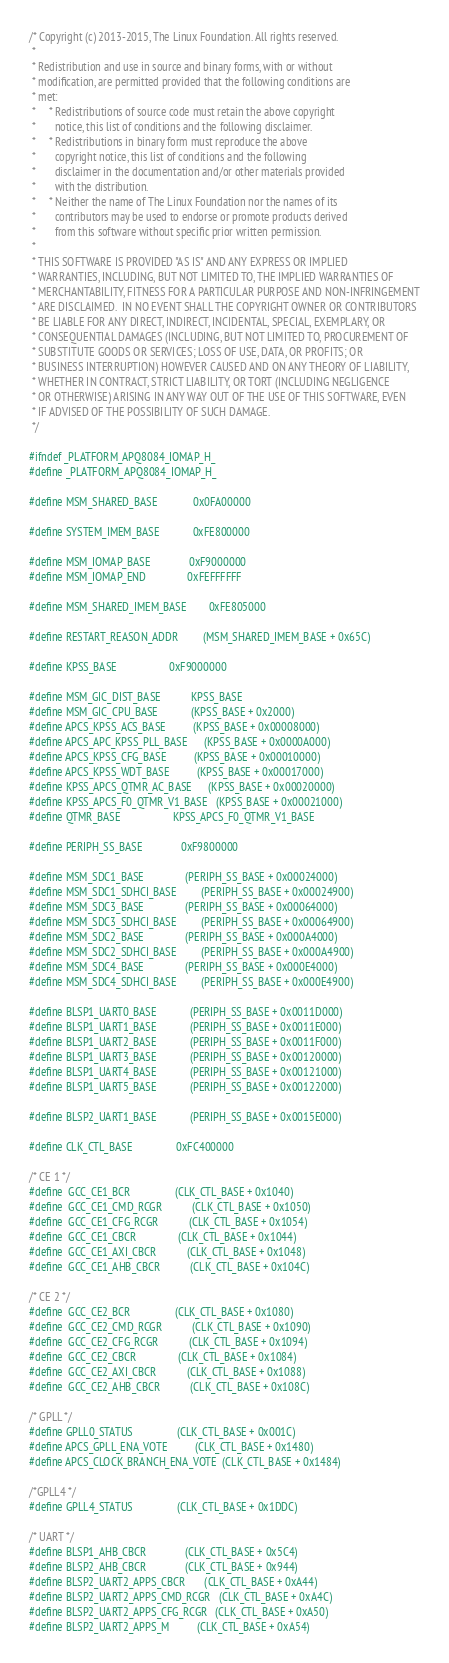Convert code to text. <code><loc_0><loc_0><loc_500><loc_500><_C_>/* Copyright (c) 2013-2015, The Linux Foundation. All rights reserved.
 *
 * Redistribution and use in source and binary forms, with or without
 * modification, are permitted provided that the following conditions are
 * met:
 *     * Redistributions of source code must retain the above copyright
 *       notice, this list of conditions and the following disclaimer.
 *     * Redistributions in binary form must reproduce the above
 *       copyright notice, this list of conditions and the following
 *       disclaimer in the documentation and/or other materials provided
 *       with the distribution.
 *     * Neither the name of The Linux Foundation nor the names of its
 *       contributors may be used to endorse or promote products derived
 *       from this software without specific prior written permission.
 *
 * THIS SOFTWARE IS PROVIDED "AS IS" AND ANY EXPRESS OR IMPLIED
 * WARRANTIES, INCLUDING, BUT NOT LIMITED TO, THE IMPLIED WARRANTIES OF
 * MERCHANTABILITY, FITNESS FOR A PARTICULAR PURPOSE AND NON-INFRINGEMENT
 * ARE DISCLAIMED.  IN NO EVENT SHALL THE COPYRIGHT OWNER OR CONTRIBUTORS
 * BE LIABLE FOR ANY DIRECT, INDIRECT, INCIDENTAL, SPECIAL, EXEMPLARY, OR
 * CONSEQUENTIAL DAMAGES (INCLUDING, BUT NOT LIMITED TO, PROCUREMENT OF
 * SUBSTITUTE GOODS OR SERVICES; LOSS OF USE, DATA, OR PROFITS; OR
 * BUSINESS INTERRUPTION) HOWEVER CAUSED AND ON ANY THEORY OF LIABILITY,
 * WHETHER IN CONTRACT, STRICT LIABILITY, OR TORT (INCLUDING NEGLIGENCE
 * OR OTHERWISE) ARISING IN ANY WAY OUT OF THE USE OF THIS SOFTWARE, EVEN
 * IF ADVISED OF THE POSSIBILITY OF SUCH DAMAGE.
 */

#ifndef _PLATFORM_APQ8084_IOMAP_H_
#define _PLATFORM_APQ8084_IOMAP_H_

#define MSM_SHARED_BASE             0x0FA00000

#define SYSTEM_IMEM_BASE            0xFE800000

#define MSM_IOMAP_BASE              0xF9000000
#define MSM_IOMAP_END               0xFEFFFFFF

#define MSM_SHARED_IMEM_BASE        0xFE805000

#define RESTART_REASON_ADDR         (MSM_SHARED_IMEM_BASE + 0x65C)

#define KPSS_BASE                   0xF9000000

#define MSM_GIC_DIST_BASE           KPSS_BASE
#define MSM_GIC_CPU_BASE            (KPSS_BASE + 0x2000)
#define APCS_KPSS_ACS_BASE          (KPSS_BASE + 0x00008000)
#define APCS_APC_KPSS_PLL_BASE      (KPSS_BASE + 0x0000A000)
#define APCS_KPSS_CFG_BASE          (KPSS_BASE + 0x00010000)
#define APCS_KPSS_WDT_BASE          (KPSS_BASE + 0x00017000)
#define KPSS_APCS_QTMR_AC_BASE      (KPSS_BASE + 0x00020000)
#define KPSS_APCS_F0_QTMR_V1_BASE   (KPSS_BASE + 0x00021000)
#define QTMR_BASE                   KPSS_APCS_F0_QTMR_V1_BASE

#define PERIPH_SS_BASE              0xF9800000

#define MSM_SDC1_BASE               (PERIPH_SS_BASE + 0x00024000)
#define MSM_SDC1_SDHCI_BASE         (PERIPH_SS_BASE + 0x00024900)
#define MSM_SDC3_BASE               (PERIPH_SS_BASE + 0x00064000)
#define MSM_SDC3_SDHCI_BASE         (PERIPH_SS_BASE + 0x00064900)
#define MSM_SDC2_BASE               (PERIPH_SS_BASE + 0x000A4000)
#define MSM_SDC2_SDHCI_BASE         (PERIPH_SS_BASE + 0x000A4900)
#define MSM_SDC4_BASE               (PERIPH_SS_BASE + 0x000E4000)
#define MSM_SDC4_SDHCI_BASE         (PERIPH_SS_BASE + 0x000E4900)

#define BLSP1_UART0_BASE            (PERIPH_SS_BASE + 0x0011D000)
#define BLSP1_UART1_BASE            (PERIPH_SS_BASE + 0x0011E000)
#define BLSP1_UART2_BASE            (PERIPH_SS_BASE + 0x0011F000)
#define BLSP1_UART3_BASE            (PERIPH_SS_BASE + 0x00120000)
#define BLSP1_UART4_BASE            (PERIPH_SS_BASE + 0x00121000)
#define BLSP1_UART5_BASE            (PERIPH_SS_BASE + 0x00122000)

#define BLSP2_UART1_BASE            (PERIPH_SS_BASE + 0x0015E000)

#define CLK_CTL_BASE                0xFC400000

/* CE 1 */
#define  GCC_CE1_BCR                (CLK_CTL_BASE + 0x1040)
#define  GCC_CE1_CMD_RCGR           (CLK_CTL_BASE + 0x1050)
#define  GCC_CE1_CFG_RCGR           (CLK_CTL_BASE + 0x1054)
#define  GCC_CE1_CBCR               (CLK_CTL_BASE + 0x1044)
#define  GCC_CE1_AXI_CBCR           (CLK_CTL_BASE + 0x1048)
#define  GCC_CE1_AHB_CBCR           (CLK_CTL_BASE + 0x104C)

/* CE 2 */
#define  GCC_CE2_BCR                (CLK_CTL_BASE + 0x1080)
#define  GCC_CE2_CMD_RCGR           (CLK_CTL_BASE + 0x1090)
#define  GCC_CE2_CFG_RCGR           (CLK_CTL_BASE + 0x1094)
#define  GCC_CE2_CBCR               (CLK_CTL_BASE + 0x1084)
#define  GCC_CE2_AXI_CBCR           (CLK_CTL_BASE + 0x1088)
#define  GCC_CE2_AHB_CBCR           (CLK_CTL_BASE + 0x108C)

/* GPLL */
#define GPLL0_STATUS                (CLK_CTL_BASE + 0x001C)
#define APCS_GPLL_ENA_VOTE          (CLK_CTL_BASE + 0x1480)
#define APCS_CLOCK_BRANCH_ENA_VOTE  (CLK_CTL_BASE + 0x1484)

/*GPLL4 */
#define GPLL4_STATUS                (CLK_CTL_BASE + 0x1DDC)

/* UART */
#define BLSP1_AHB_CBCR              (CLK_CTL_BASE + 0x5C4)
#define BLSP2_AHB_CBCR              (CLK_CTL_BASE + 0x944)
#define BLSP2_UART2_APPS_CBCR       (CLK_CTL_BASE + 0xA44)
#define BLSP2_UART2_APPS_CMD_RCGR   (CLK_CTL_BASE + 0xA4C)
#define BLSP2_UART2_APPS_CFG_RCGR   (CLK_CTL_BASE + 0xA50)
#define BLSP2_UART2_APPS_M          (CLK_CTL_BASE + 0xA54)</code> 